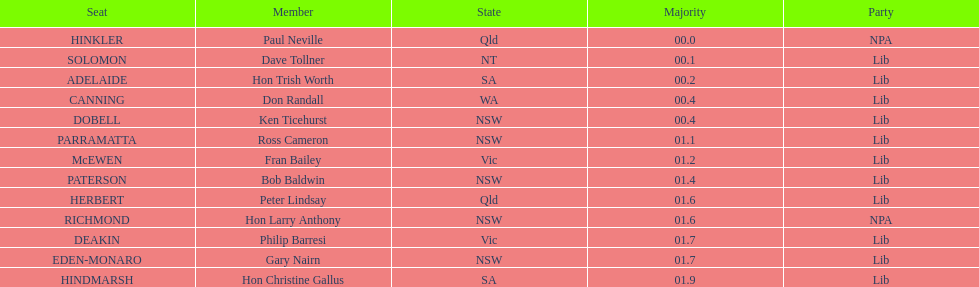How many members in total? 13. 